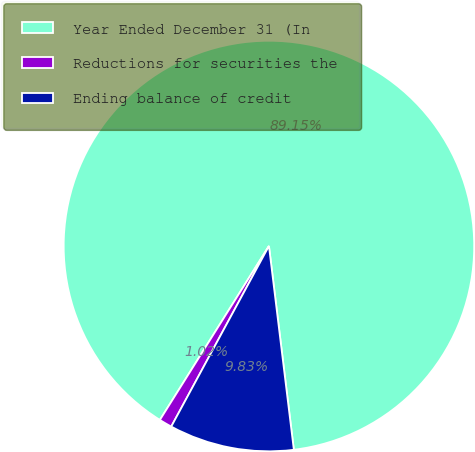<chart> <loc_0><loc_0><loc_500><loc_500><pie_chart><fcel>Year Ended December 31 (In<fcel>Reductions for securities the<fcel>Ending balance of credit<nl><fcel>89.15%<fcel>1.02%<fcel>9.83%<nl></chart> 